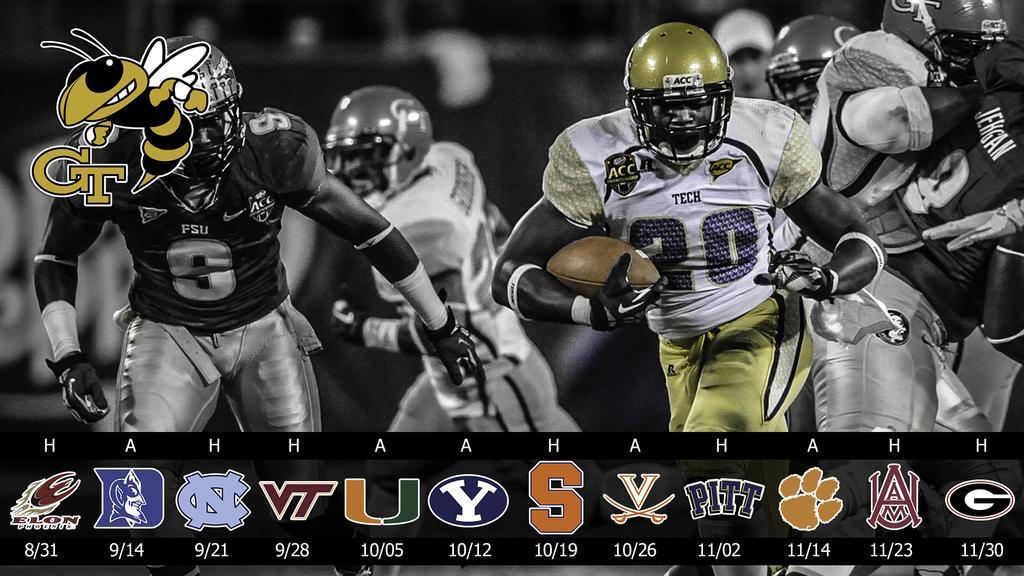Please provide a concise description of this image. In this picture we can see men wearing helmets and it seems like they a playing a rugby game. This is a rugby ball. At the bottom portion of the picture we can see team logos and scores. 